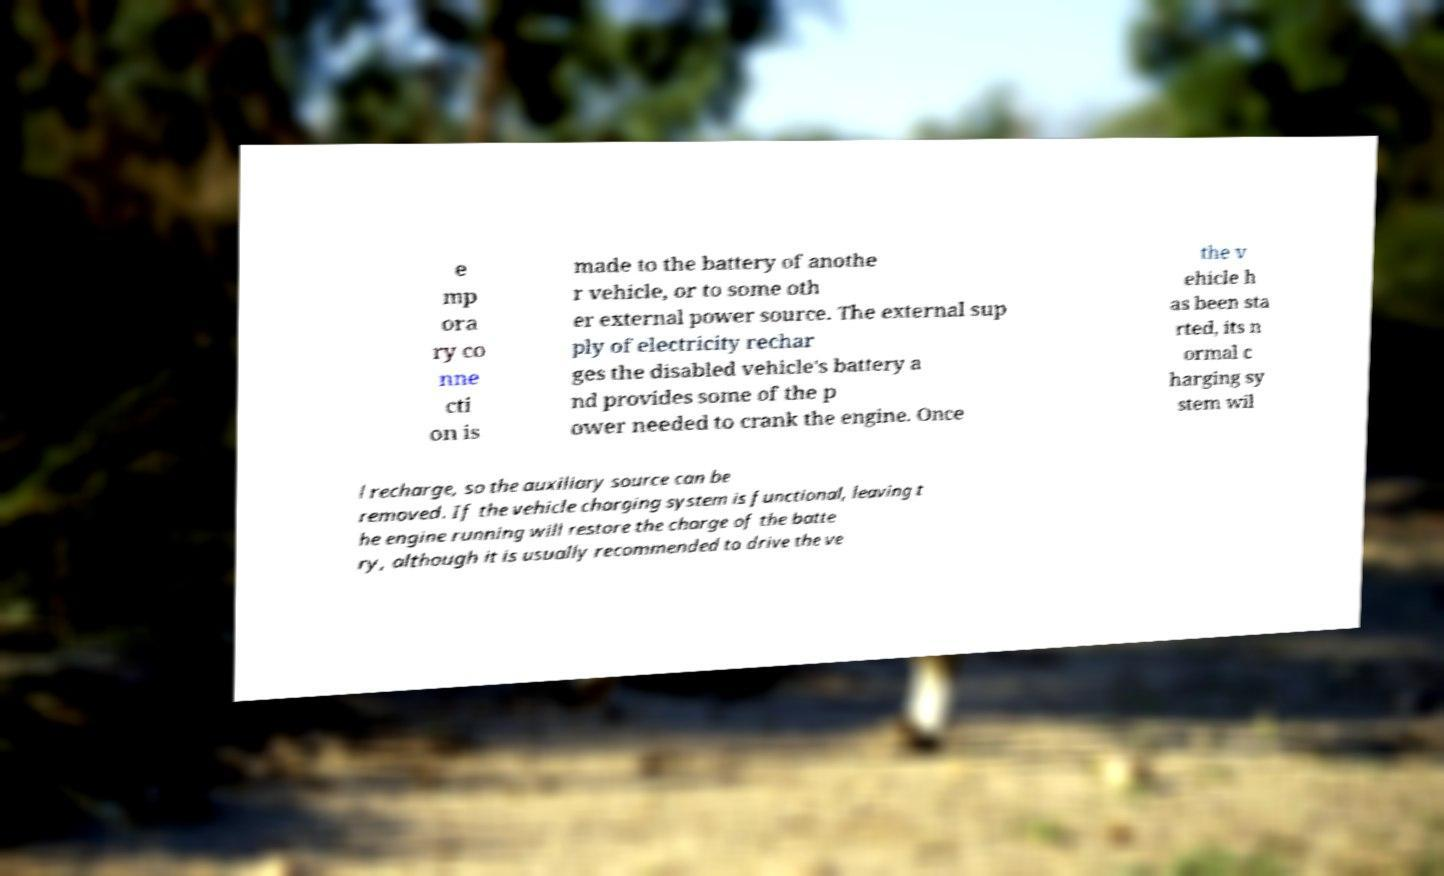Please read and relay the text visible in this image. What does it say? e mp ora ry co nne cti on is made to the battery of anothe r vehicle, or to some oth er external power source. The external sup ply of electricity rechar ges the disabled vehicle's battery a nd provides some of the p ower needed to crank the engine. Once the v ehicle h as been sta rted, its n ormal c harging sy stem wil l recharge, so the auxiliary source can be removed. If the vehicle charging system is functional, leaving t he engine running will restore the charge of the batte ry, although it is usually recommended to drive the ve 